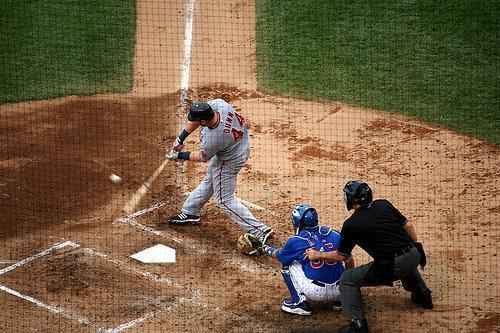How many people are on the field?
Give a very brief answer. 3. 